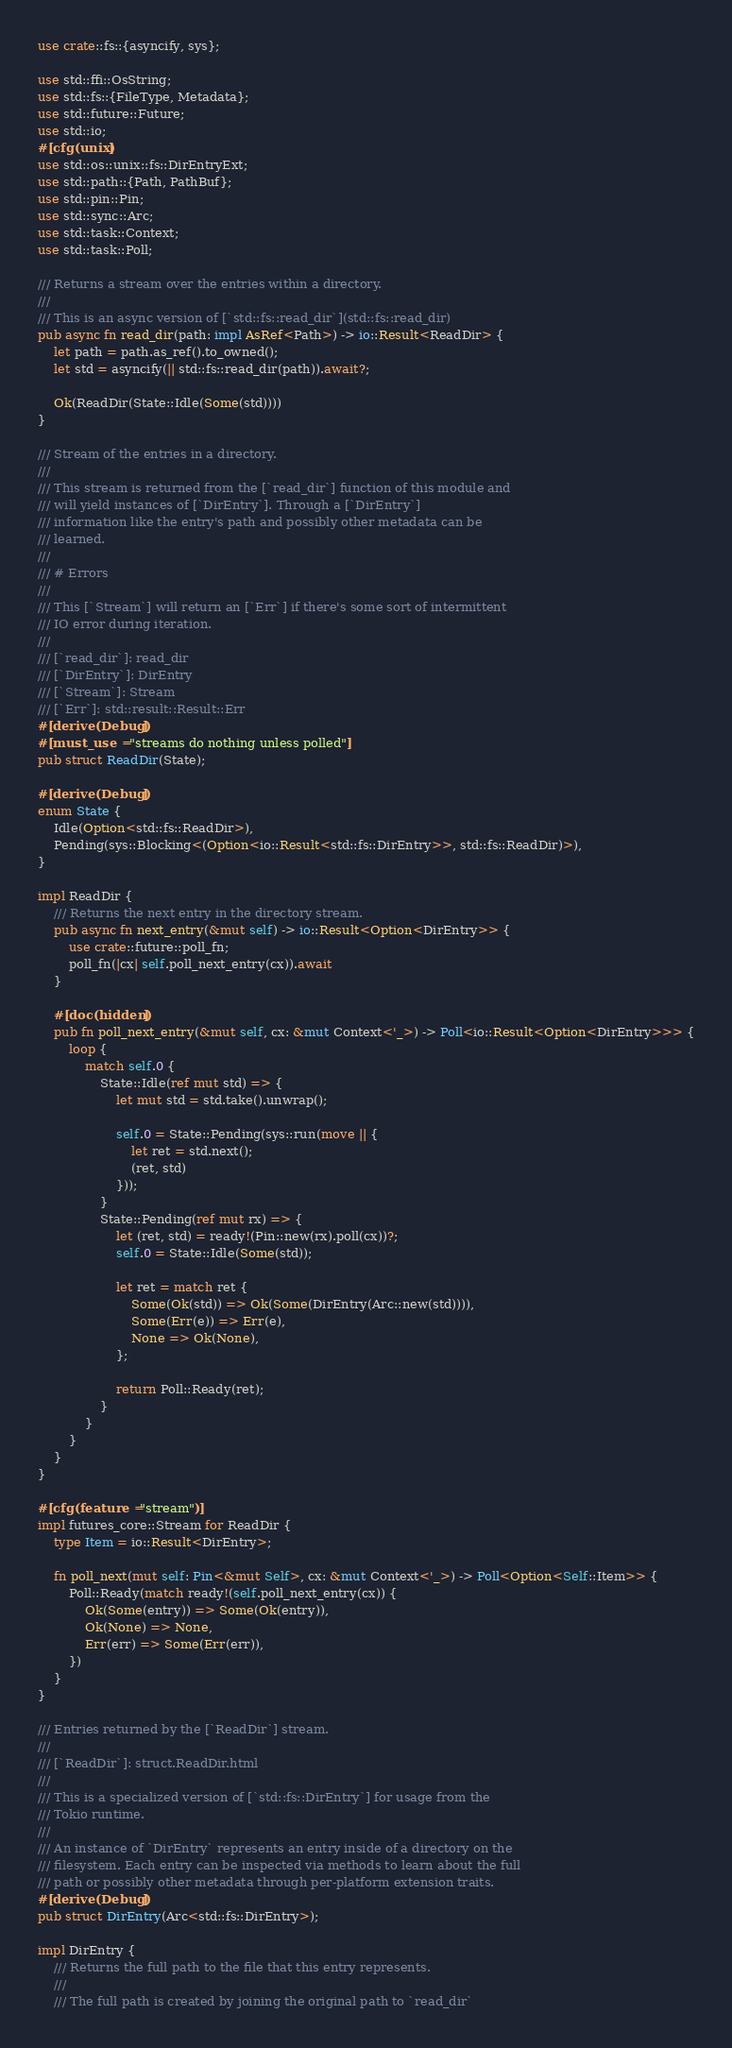Convert code to text. <code><loc_0><loc_0><loc_500><loc_500><_Rust_>use crate::fs::{asyncify, sys};

use std::ffi::OsString;
use std::fs::{FileType, Metadata};
use std::future::Future;
use std::io;
#[cfg(unix)]
use std::os::unix::fs::DirEntryExt;
use std::path::{Path, PathBuf};
use std::pin::Pin;
use std::sync::Arc;
use std::task::Context;
use std::task::Poll;

/// Returns a stream over the entries within a directory.
///
/// This is an async version of [`std::fs::read_dir`](std::fs::read_dir)
pub async fn read_dir(path: impl AsRef<Path>) -> io::Result<ReadDir> {
    let path = path.as_ref().to_owned();
    let std = asyncify(|| std::fs::read_dir(path)).await?;

    Ok(ReadDir(State::Idle(Some(std))))
}

/// Stream of the entries in a directory.
///
/// This stream is returned from the [`read_dir`] function of this module and
/// will yield instances of [`DirEntry`]. Through a [`DirEntry`]
/// information like the entry's path and possibly other metadata can be
/// learned.
///
/// # Errors
///
/// This [`Stream`] will return an [`Err`] if there's some sort of intermittent
/// IO error during iteration.
///
/// [`read_dir`]: read_dir
/// [`DirEntry`]: DirEntry
/// [`Stream`]: Stream
/// [`Err`]: std::result::Result::Err
#[derive(Debug)]
#[must_use = "streams do nothing unless polled"]
pub struct ReadDir(State);

#[derive(Debug)]
enum State {
    Idle(Option<std::fs::ReadDir>),
    Pending(sys::Blocking<(Option<io::Result<std::fs::DirEntry>>, std::fs::ReadDir)>),
}

impl ReadDir {
    /// Returns the next entry in the directory stream.
    pub async fn next_entry(&mut self) -> io::Result<Option<DirEntry>> {
        use crate::future::poll_fn;
        poll_fn(|cx| self.poll_next_entry(cx)).await
    }

    #[doc(hidden)]
    pub fn poll_next_entry(&mut self, cx: &mut Context<'_>) -> Poll<io::Result<Option<DirEntry>>> {
        loop {
            match self.0 {
                State::Idle(ref mut std) => {
                    let mut std = std.take().unwrap();

                    self.0 = State::Pending(sys::run(move || {
                        let ret = std.next();
                        (ret, std)
                    }));
                }
                State::Pending(ref mut rx) => {
                    let (ret, std) = ready!(Pin::new(rx).poll(cx))?;
                    self.0 = State::Idle(Some(std));

                    let ret = match ret {
                        Some(Ok(std)) => Ok(Some(DirEntry(Arc::new(std)))),
                        Some(Err(e)) => Err(e),
                        None => Ok(None),
                    };

                    return Poll::Ready(ret);
                }
            }
        }
    }
}

#[cfg(feature = "stream")]
impl futures_core::Stream for ReadDir {
    type Item = io::Result<DirEntry>;

    fn poll_next(mut self: Pin<&mut Self>, cx: &mut Context<'_>) -> Poll<Option<Self::Item>> {
        Poll::Ready(match ready!(self.poll_next_entry(cx)) {
            Ok(Some(entry)) => Some(Ok(entry)),
            Ok(None) => None,
            Err(err) => Some(Err(err)),
        })
    }
}

/// Entries returned by the [`ReadDir`] stream.
///
/// [`ReadDir`]: struct.ReadDir.html
///
/// This is a specialized version of [`std::fs::DirEntry`] for usage from the
/// Tokio runtime.
///
/// An instance of `DirEntry` represents an entry inside of a directory on the
/// filesystem. Each entry can be inspected via methods to learn about the full
/// path or possibly other metadata through per-platform extension traits.
#[derive(Debug)]
pub struct DirEntry(Arc<std::fs::DirEntry>);

impl DirEntry {
    /// Returns the full path to the file that this entry represents.
    ///
    /// The full path is created by joining the original path to `read_dir`</code> 